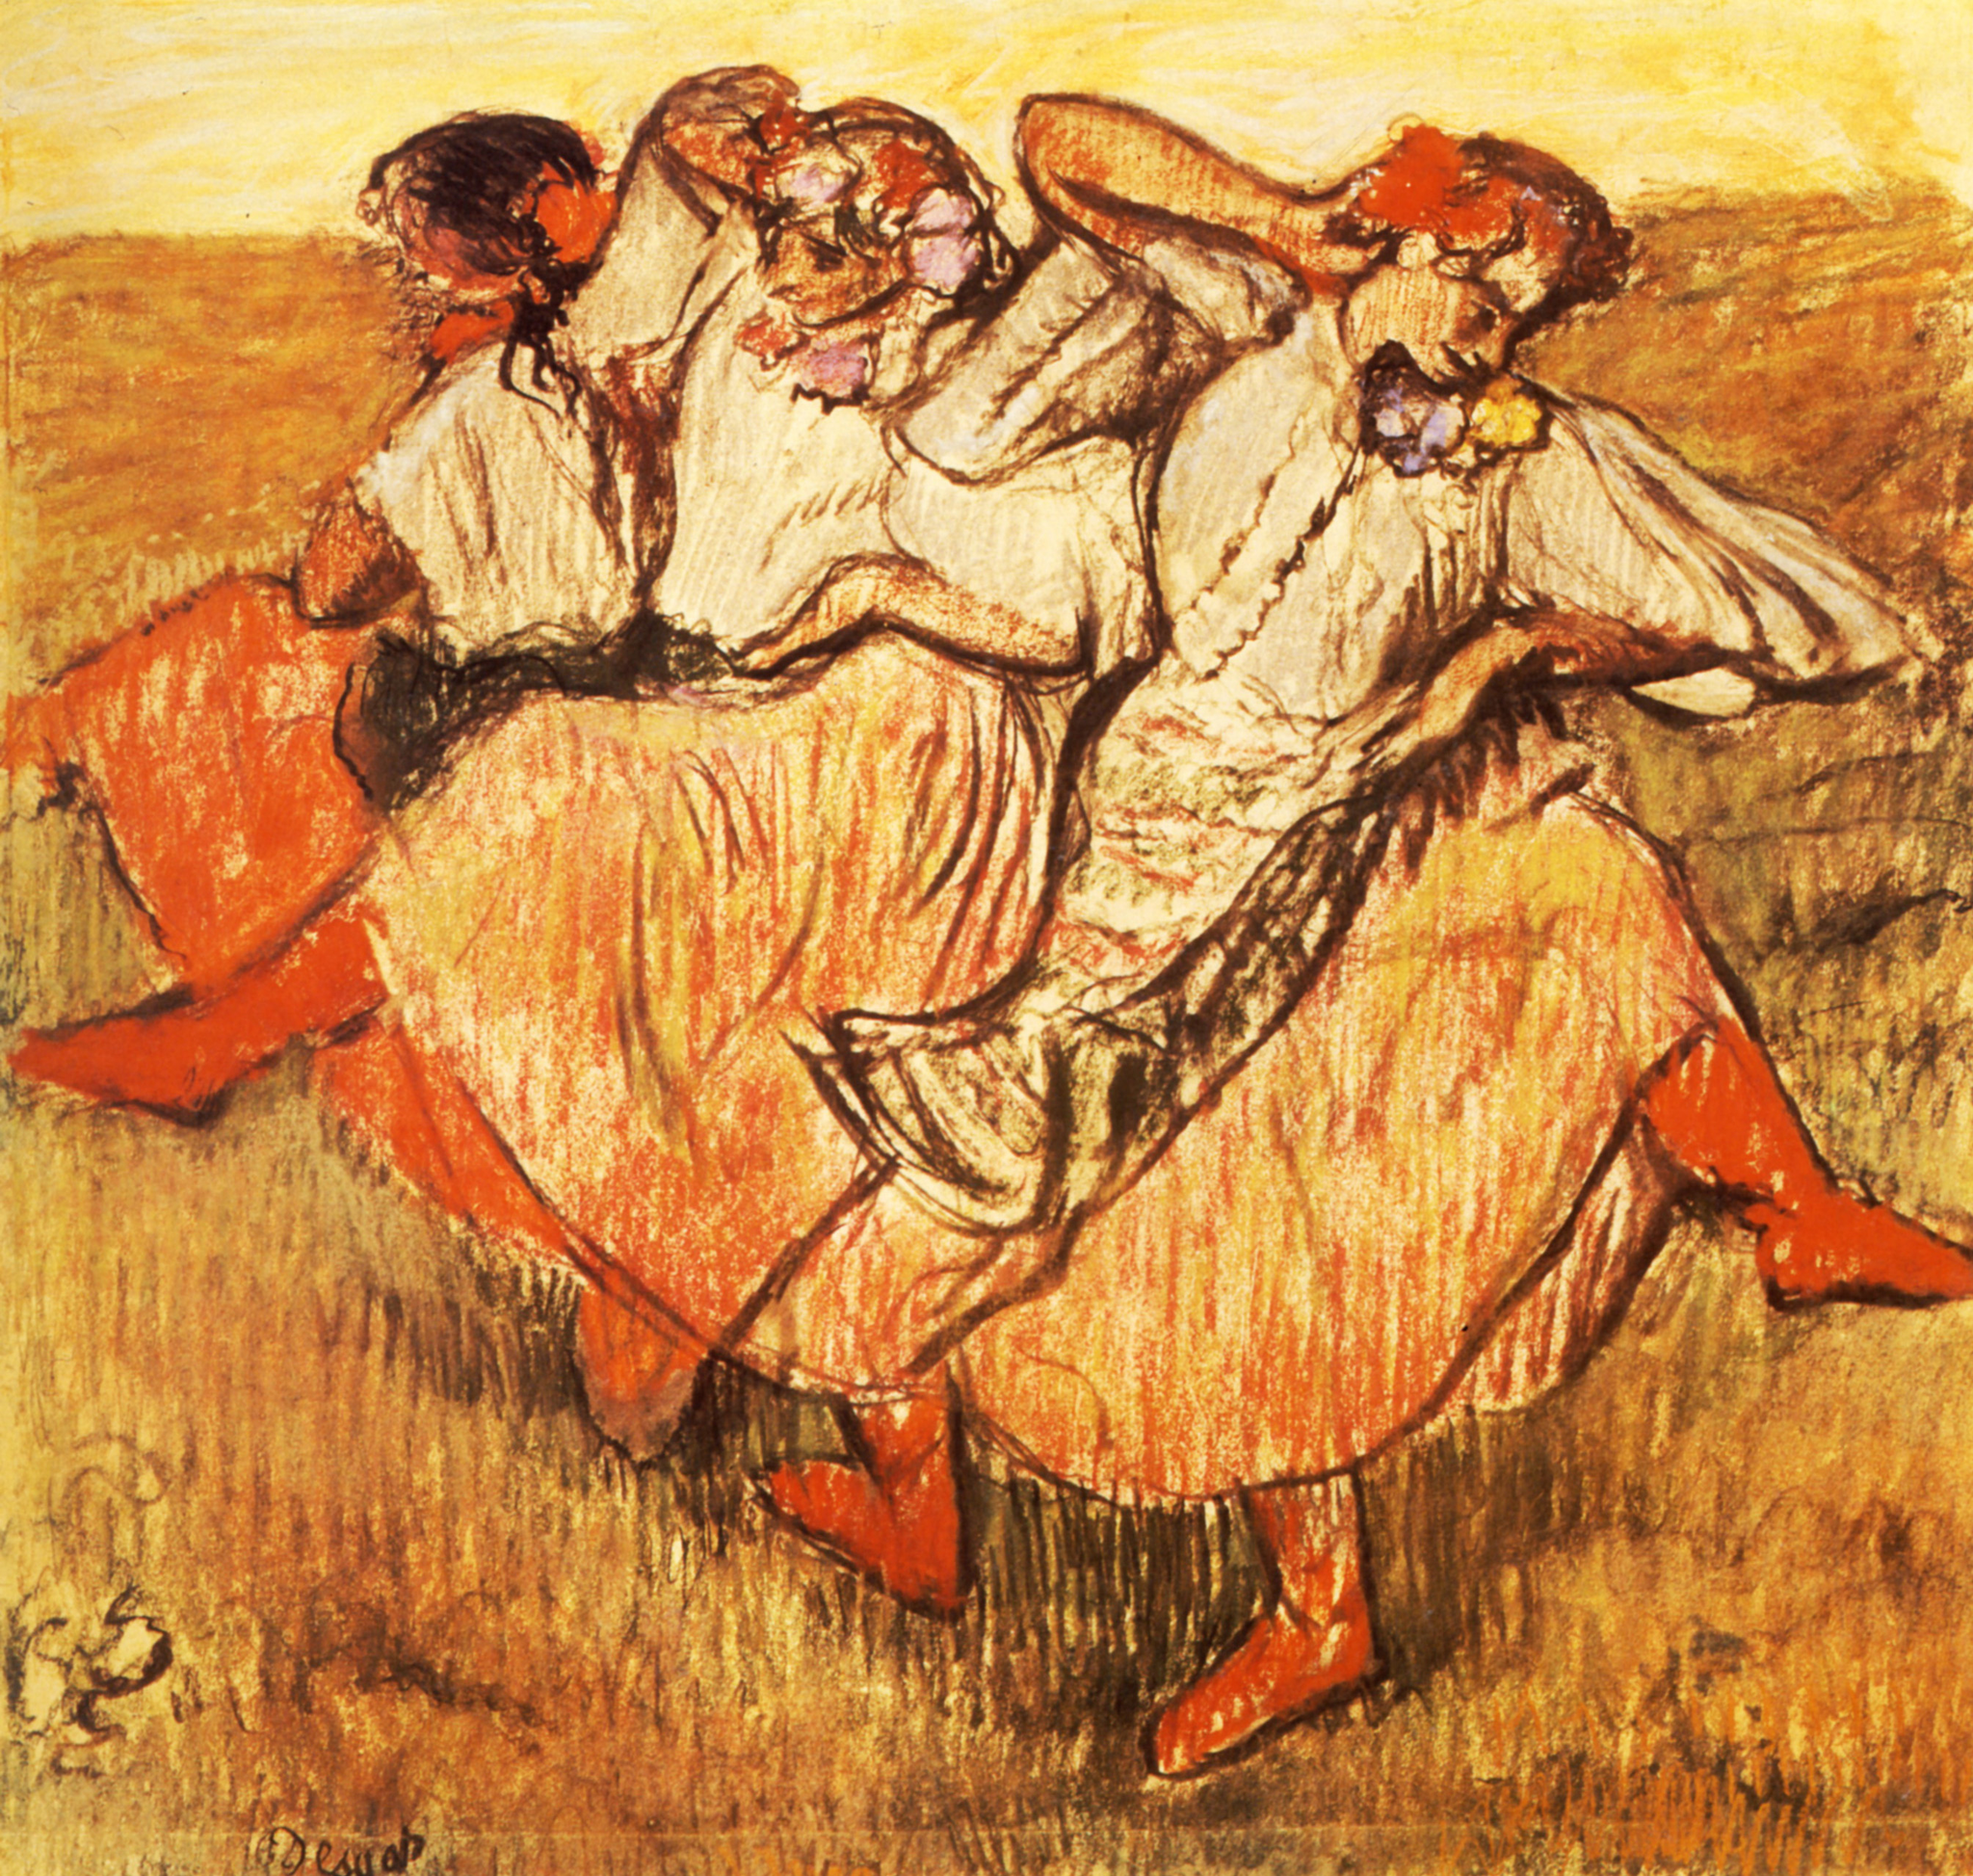What can we infer about the setting and time of day in this painting? The setting appears to be an open field, likely a rural or pastoral landscape. With the dominance of golden and warm tones that bathe the scene, it's plausible to infer that the painting captures a moment in the late afternoon. The long shadows and the way the light infuses the scene with a warm glow suggest that the sun is low in the sky, which is a common characteristic of the 'golden hour' before sunset. 